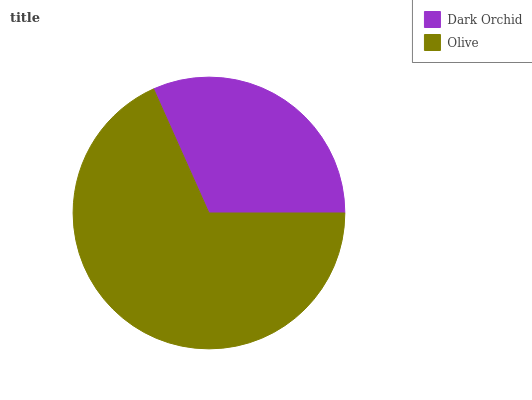Is Dark Orchid the minimum?
Answer yes or no. Yes. Is Olive the maximum?
Answer yes or no. Yes. Is Olive the minimum?
Answer yes or no. No. Is Olive greater than Dark Orchid?
Answer yes or no. Yes. Is Dark Orchid less than Olive?
Answer yes or no. Yes. Is Dark Orchid greater than Olive?
Answer yes or no. No. Is Olive less than Dark Orchid?
Answer yes or no. No. Is Olive the high median?
Answer yes or no. Yes. Is Dark Orchid the low median?
Answer yes or no. Yes. Is Dark Orchid the high median?
Answer yes or no. No. Is Olive the low median?
Answer yes or no. No. 